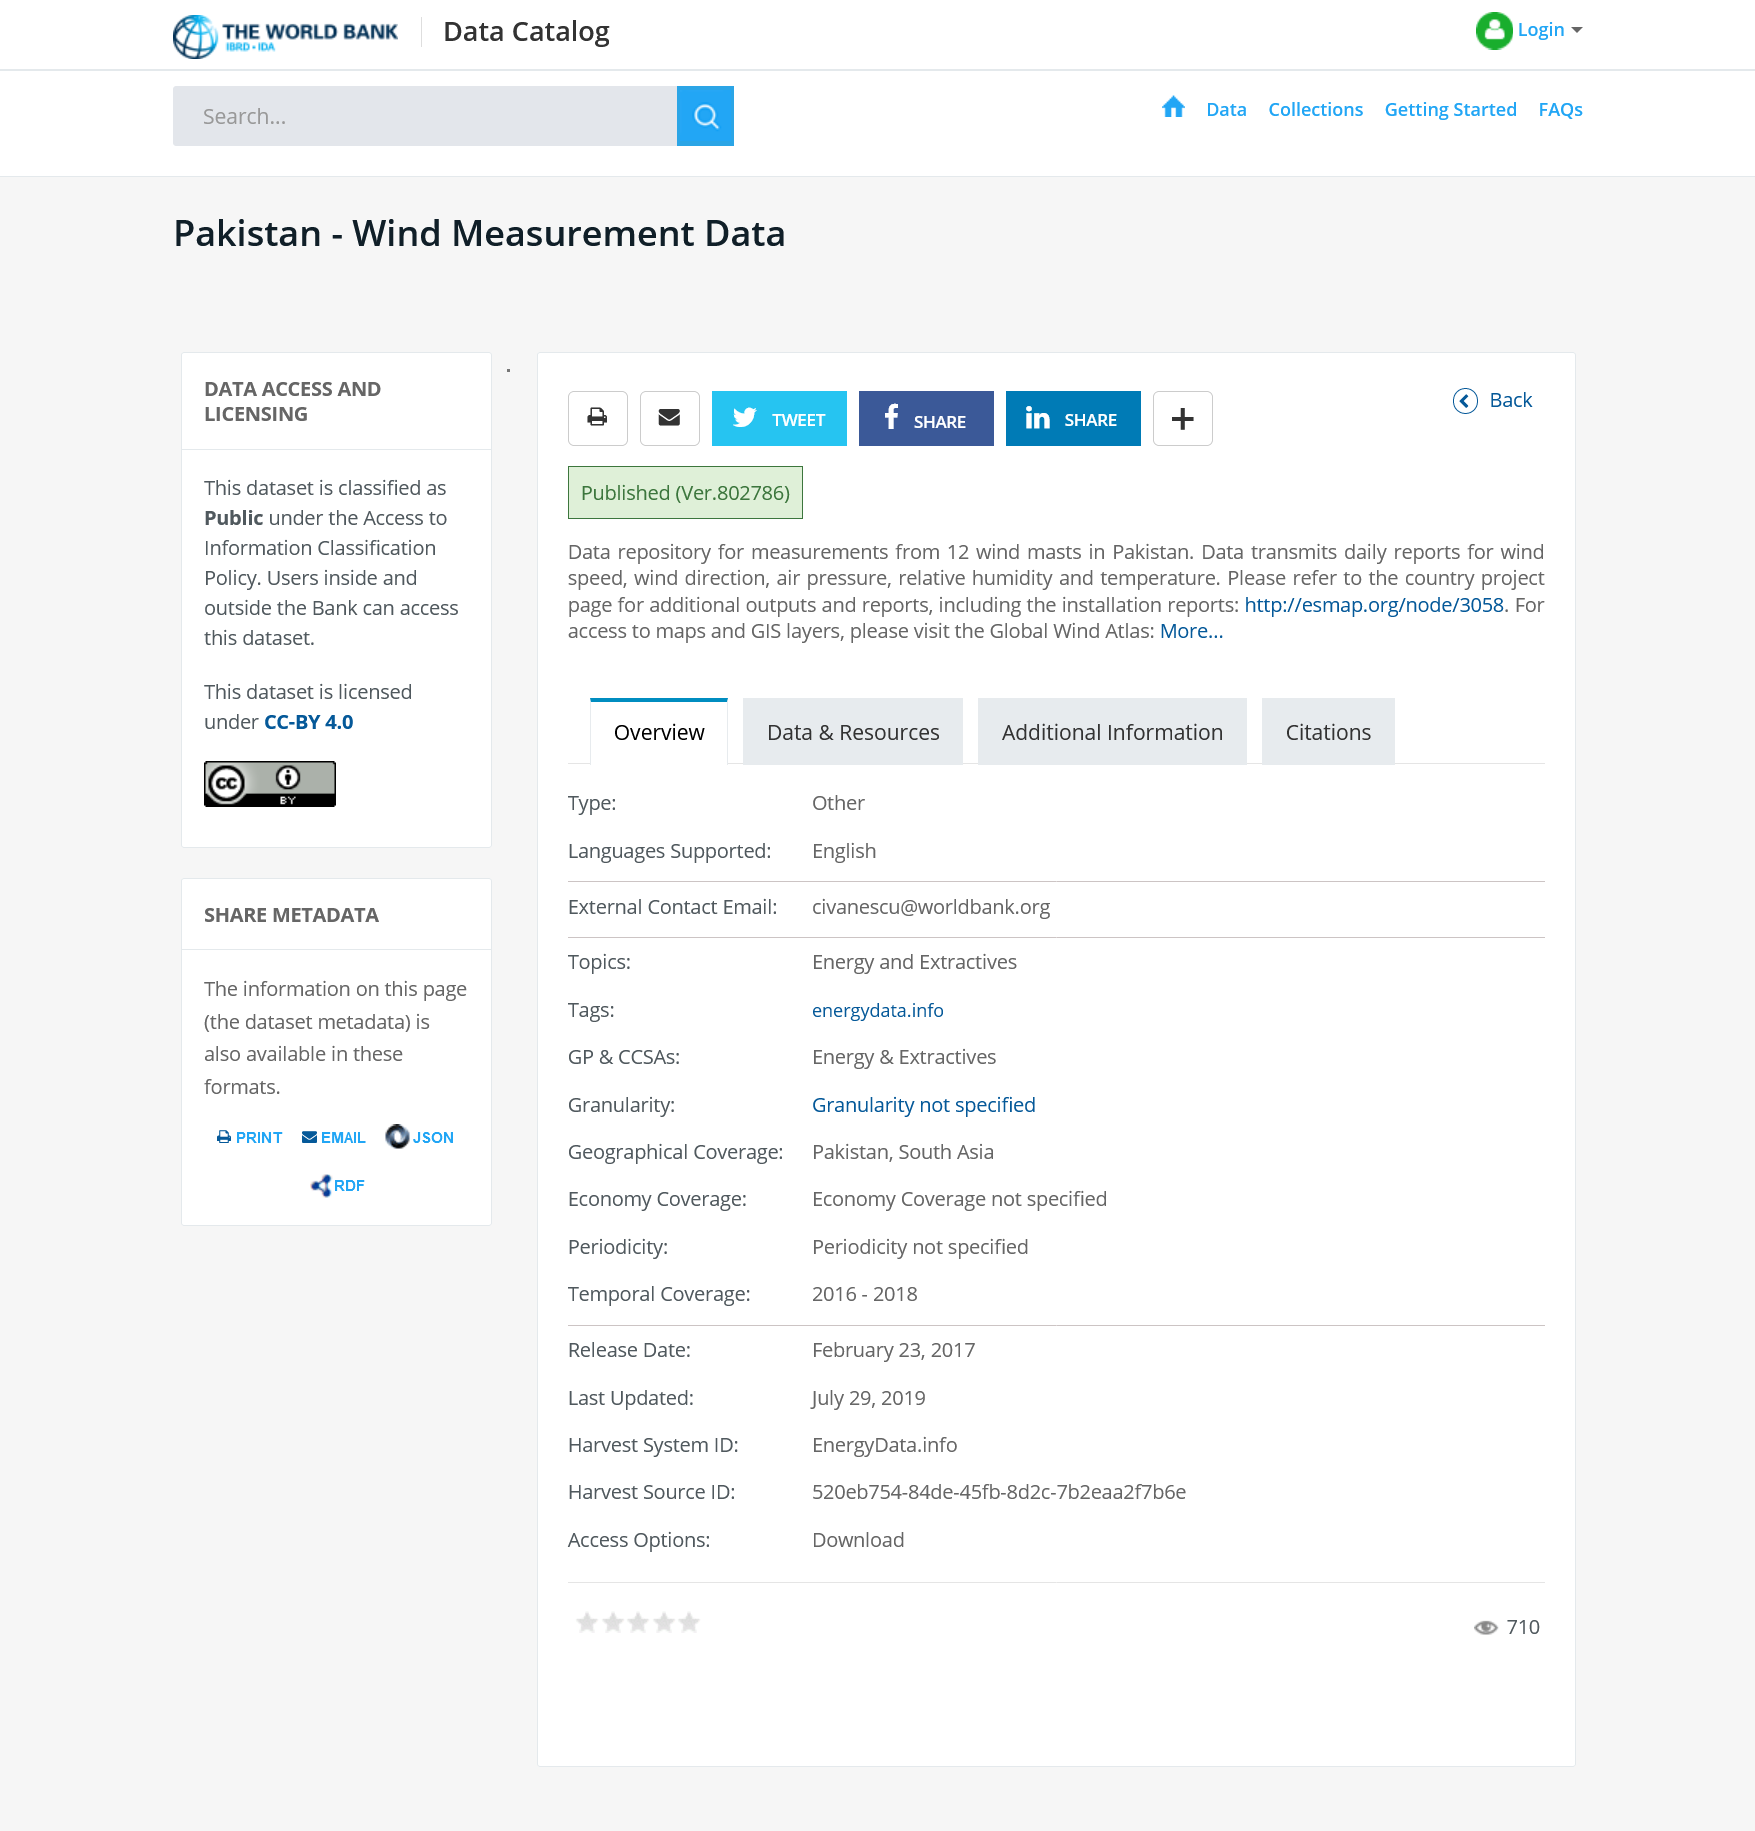List a handful of essential elements in this visual. This page is about data and its various aspects, such as types, sources, and applications. Yes, it is shareable on Twitter. The fact that this share can be posted on Facebook is a definite possibility. 